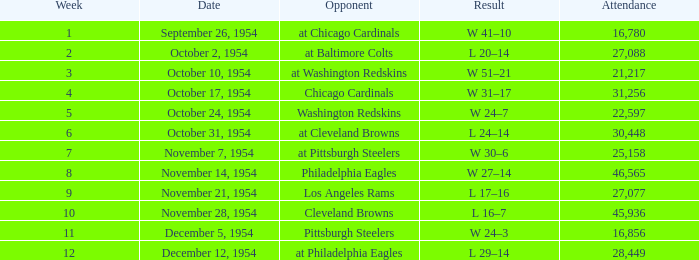In how many weeks does october 31, 1954 fall? 1.0. 